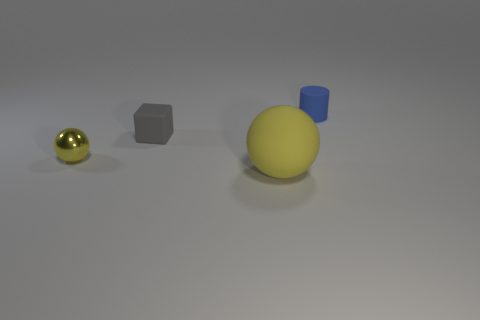Are there any other things that are the same size as the yellow matte object?
Your answer should be very brief. No. What color is the object in front of the yellow sphere to the left of the small rubber thing that is in front of the tiny matte cylinder?
Keep it short and to the point. Yellow. How many other things are the same color as the tiny block?
Provide a short and direct response. 0. How many rubber things are tiny blue cylinders or spheres?
Make the answer very short. 2. There is a large object in front of the metal ball; is its color the same as the tiny thing in front of the small matte block?
Provide a succinct answer. Yes. Are there any other things that are the same material as the tiny blue thing?
Provide a short and direct response. Yes. There is another yellow thing that is the same shape as the small yellow thing; what is its size?
Provide a succinct answer. Large. Is the number of large objects that are left of the big yellow matte ball greater than the number of cubes?
Give a very brief answer. No. Are the ball that is on the right side of the small gray matte cube and the tiny cylinder made of the same material?
Offer a terse response. Yes. There is a yellow ball that is right of the yellow ball left of the large yellow rubber sphere in front of the tiny yellow ball; how big is it?
Provide a short and direct response. Large. 